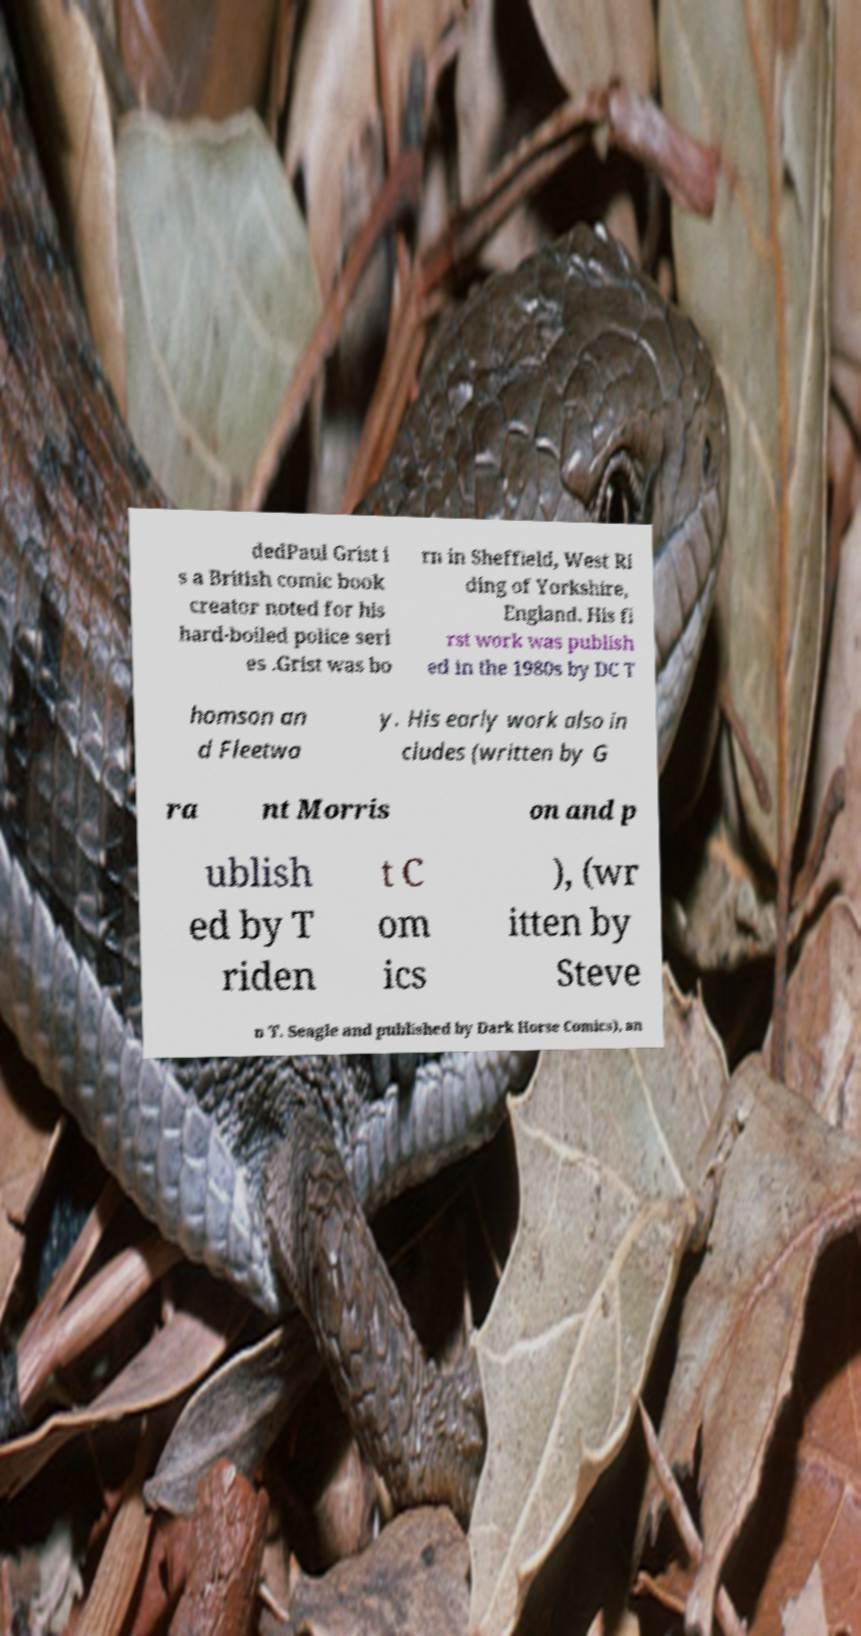Can you read and provide the text displayed in the image?This photo seems to have some interesting text. Can you extract and type it out for me? dedPaul Grist i s a British comic book creator noted for his hard-boiled police seri es .Grist was bo rn in Sheffield, West Ri ding of Yorkshire, England. His fi rst work was publish ed in the 1980s by DC T homson an d Fleetwa y. His early work also in cludes (written by G ra nt Morris on and p ublish ed by T riden t C om ics ), (wr itten by Steve n T. Seagle and published by Dark Horse Comics), an 